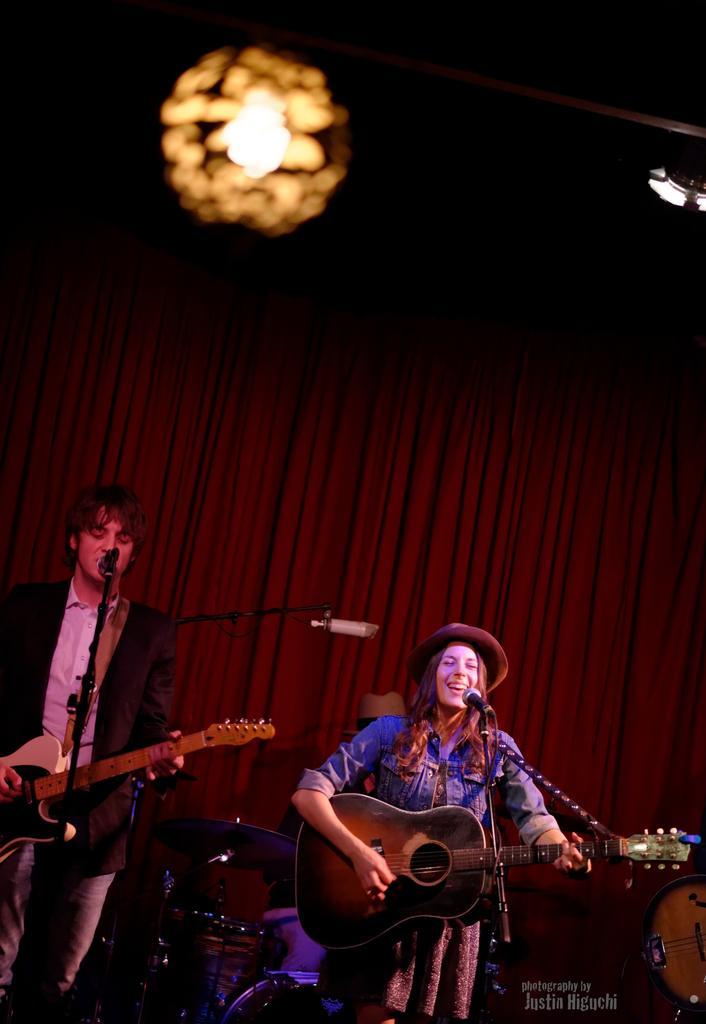Could you give a brief overview of what you see in this image? This 2 persons are playing a guitar in-front of mic. This is a red curtain. On top there is a light. These are musical instruments. 